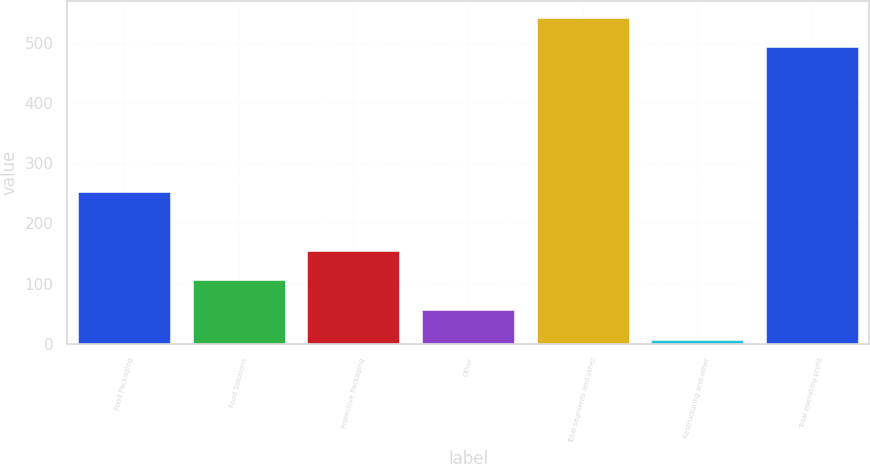Convert chart. <chart><loc_0><loc_0><loc_500><loc_500><bar_chart><fcel>Food Packaging<fcel>Food Solutions<fcel>Protective Packaging<fcel>Other<fcel>Total segments and other<fcel>Restructuring and other<fcel>Total operating profit<nl><fcel>251.7<fcel>105.46<fcel>154.69<fcel>56.23<fcel>541.53<fcel>7<fcel>492.3<nl></chart> 